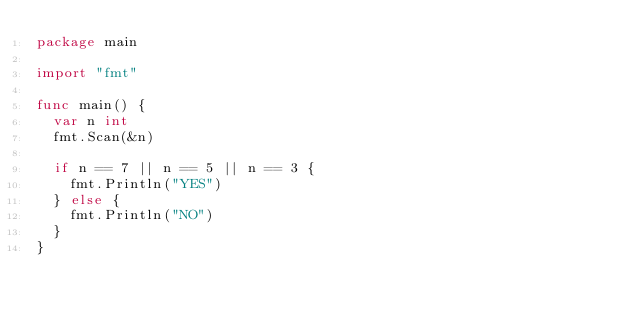<code> <loc_0><loc_0><loc_500><loc_500><_Go_>package main

import "fmt"

func main() {
	var n int
	fmt.Scan(&n)

	if n == 7 || n == 5 || n == 3 {
		fmt.Println("YES")
	} else {
		fmt.Println("NO")
	}
}
</code> 